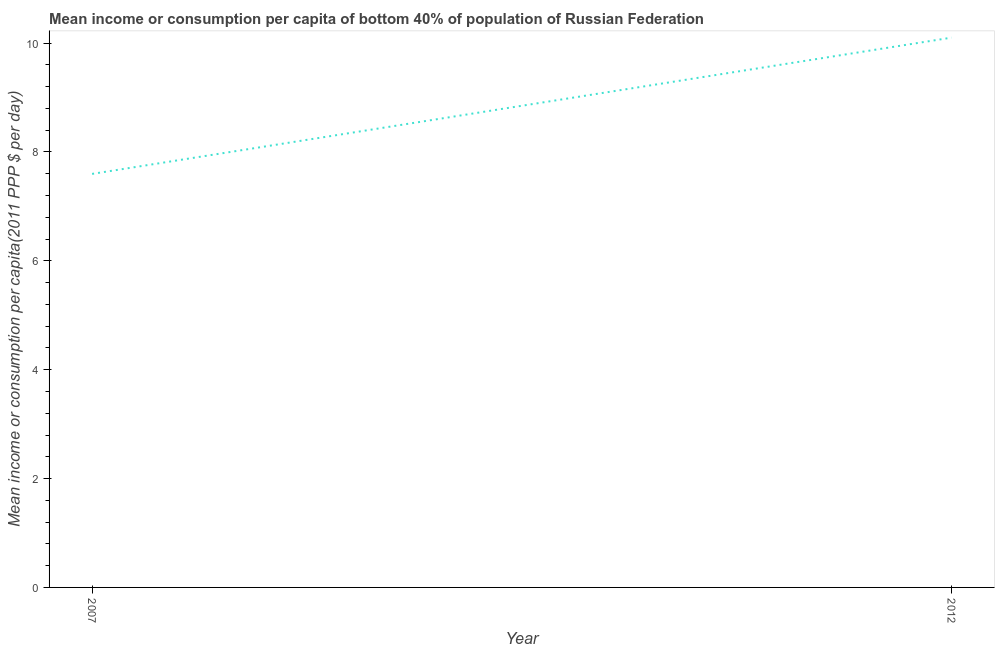What is the mean income or consumption in 2007?
Your answer should be compact. 7.6. Across all years, what is the maximum mean income or consumption?
Your answer should be very brief. 10.1. Across all years, what is the minimum mean income or consumption?
Your answer should be compact. 7.6. In which year was the mean income or consumption maximum?
Keep it short and to the point. 2012. What is the sum of the mean income or consumption?
Your response must be concise. 17.7. What is the difference between the mean income or consumption in 2007 and 2012?
Your answer should be very brief. -2.5. What is the average mean income or consumption per year?
Provide a succinct answer. 8.85. What is the median mean income or consumption?
Your response must be concise. 8.85. In how many years, is the mean income or consumption greater than 9.2 $?
Provide a short and direct response. 1. Do a majority of the years between 2012 and 2007 (inclusive) have mean income or consumption greater than 0.4 $?
Your answer should be compact. No. What is the ratio of the mean income or consumption in 2007 to that in 2012?
Offer a very short reply. 0.75. Is the mean income or consumption in 2007 less than that in 2012?
Your answer should be compact. Yes. Does the mean income or consumption monotonically increase over the years?
Your answer should be compact. Yes. How many years are there in the graph?
Provide a short and direct response. 2. Does the graph contain grids?
Offer a terse response. No. What is the title of the graph?
Give a very brief answer. Mean income or consumption per capita of bottom 40% of population of Russian Federation. What is the label or title of the Y-axis?
Your response must be concise. Mean income or consumption per capita(2011 PPP $ per day). What is the Mean income or consumption per capita(2011 PPP $ per day) in 2007?
Your response must be concise. 7.6. What is the Mean income or consumption per capita(2011 PPP $ per day) of 2012?
Make the answer very short. 10.1. What is the difference between the Mean income or consumption per capita(2011 PPP $ per day) in 2007 and 2012?
Offer a terse response. -2.5. What is the ratio of the Mean income or consumption per capita(2011 PPP $ per day) in 2007 to that in 2012?
Offer a very short reply. 0.75. 